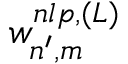Convert formula to latex. <formula><loc_0><loc_0><loc_500><loc_500>w _ { n ^ { \prime } , m } ^ { n l p , ( L ) }</formula> 